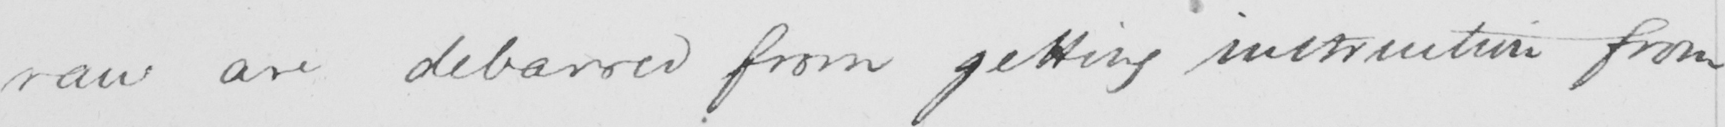What does this handwritten line say? raw are debarred from getting instruction from 